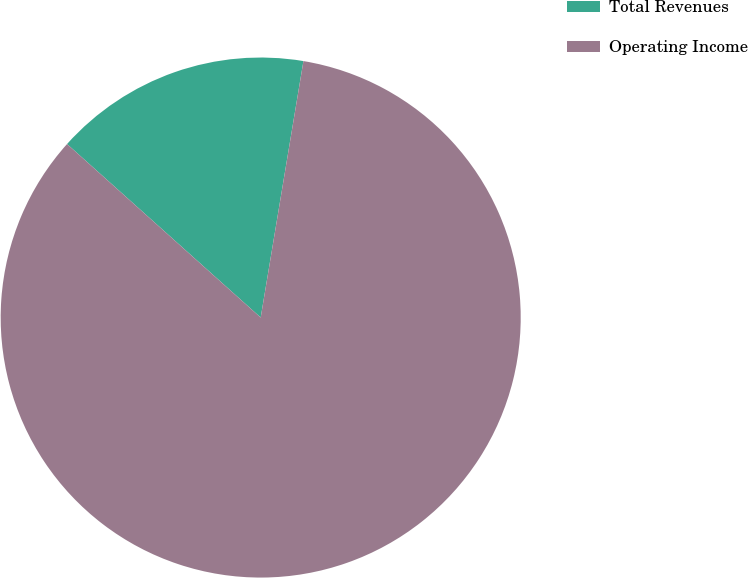Convert chart to OTSL. <chart><loc_0><loc_0><loc_500><loc_500><pie_chart><fcel>Total Revenues<fcel>Operating Income<nl><fcel>16.0%<fcel>84.0%<nl></chart> 